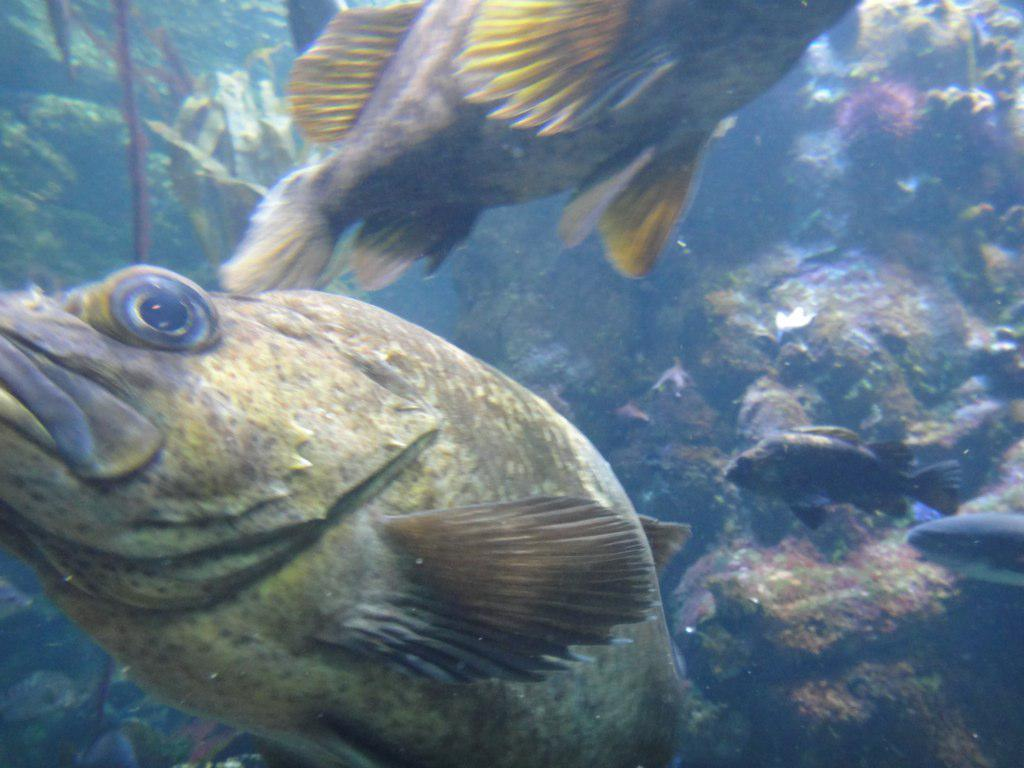Where is the picture taken? The picture is taken inside the water. What can be seen swimming in the water? There are fishes in the image. What is visible in the background of the image? There are water objects and plants in the background. Is there any geological feature in the background? Yes, there is a rock in the background. What type of steam can be seen coming from the fishes in the image? There is no steam present in the image; it is taken underwater with fishes and other background elements. Can you tell me how many laborers are working in the background of the image? There are no laborers present in the image; it features underwater scenery with fishes and background elements. 